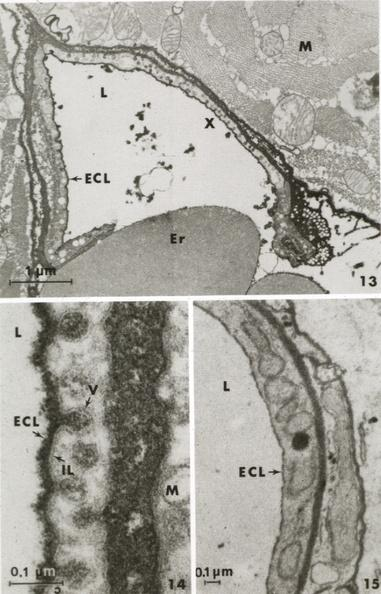what is present?
Answer the question using a single word or phrase. Cardiovascular 